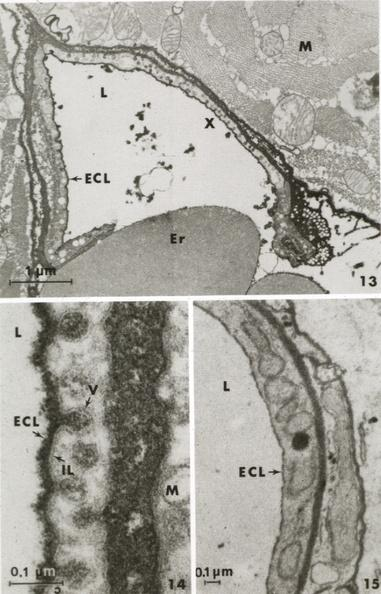what is present?
Answer the question using a single word or phrase. Cardiovascular 